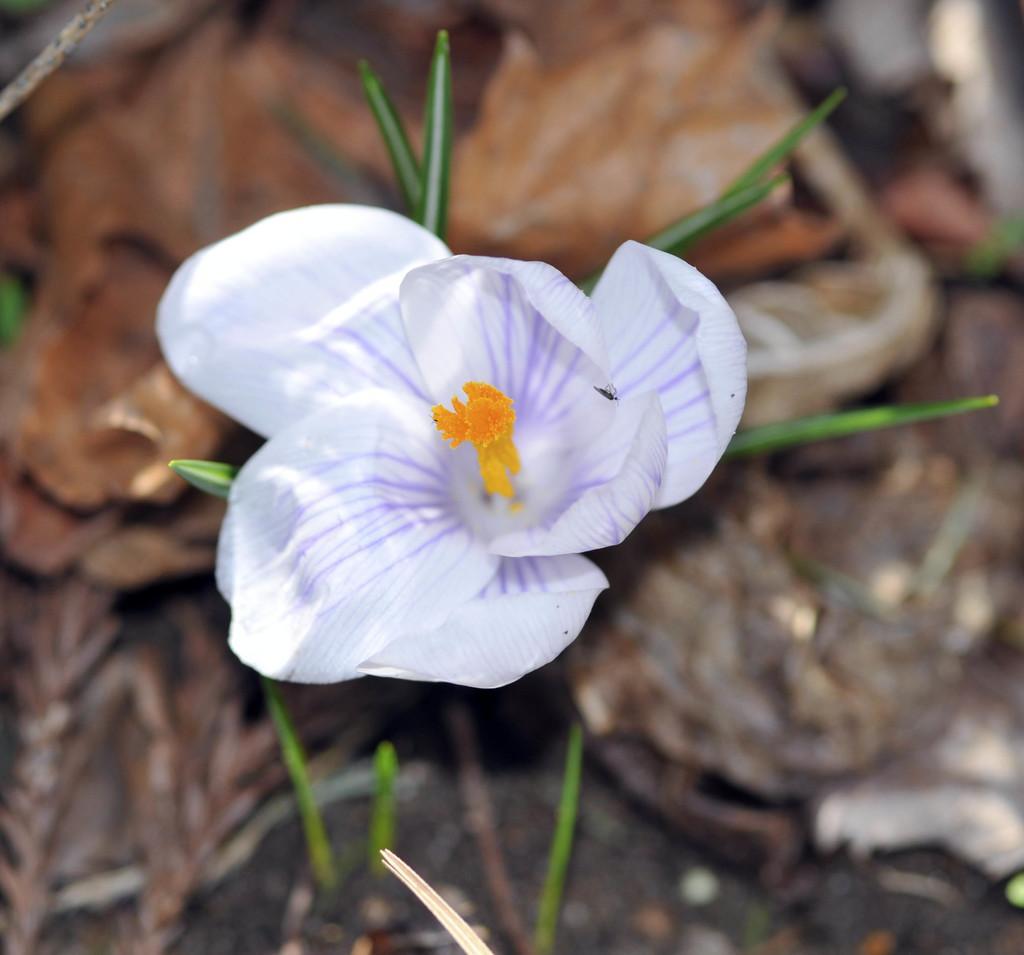Can you describe this image briefly? In this image we can see a flower with some leaves. 